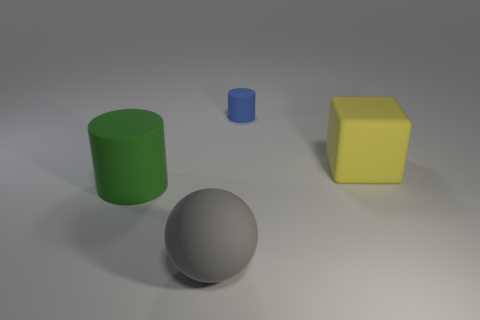What size is the thing that is both on the right side of the big cylinder and left of the blue matte object?
Your answer should be compact. Large. There is a big object that is in front of the matte cylinder in front of the yellow matte object; what shape is it?
Make the answer very short. Sphere. Is there anything else that has the same shape as the large yellow object?
Provide a succinct answer. No. Are there an equal number of objects that are on the right side of the large yellow block and gray things?
Your answer should be very brief. No. The large matte object that is both to the right of the green thing and behind the large gray object is what color?
Ensure brevity in your answer.  Yellow. There is a rubber cylinder that is in front of the large matte block; what number of small matte objects are in front of it?
Your answer should be very brief. 0. Is there a tiny thing that has the same shape as the big green thing?
Offer a very short reply. Yes. There is a large matte thing that is on the right side of the blue rubber object; is its shape the same as the big thing left of the large gray rubber sphere?
Offer a very short reply. No. What number of objects are small matte cylinders or large gray rubber objects?
Your answer should be very brief. 2. There is another thing that is the same shape as the green object; what size is it?
Offer a terse response. Small. 